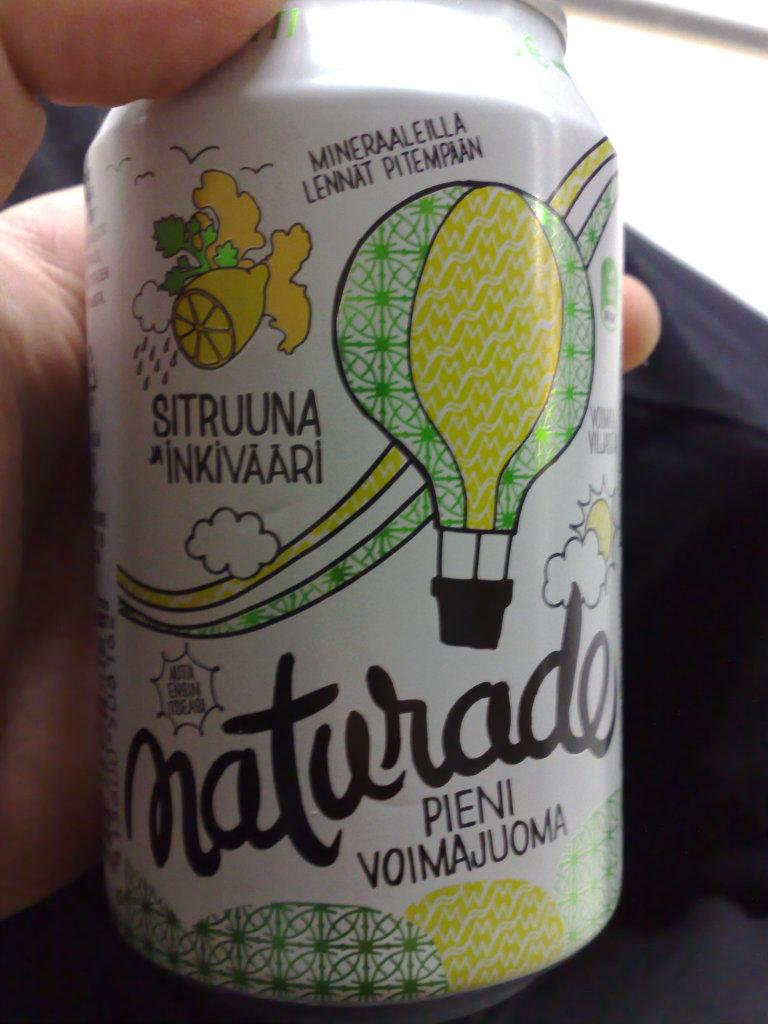Who or what is present in the image? There is a person in the image. What is the person holding in the image? The person is holding a tin in the image. Can you describe the tin in more detail? The tin has pictures and text on it. What type of bell can be heard ringing in the image? There is no bell present in the image, and therefore no sound can be heard. 